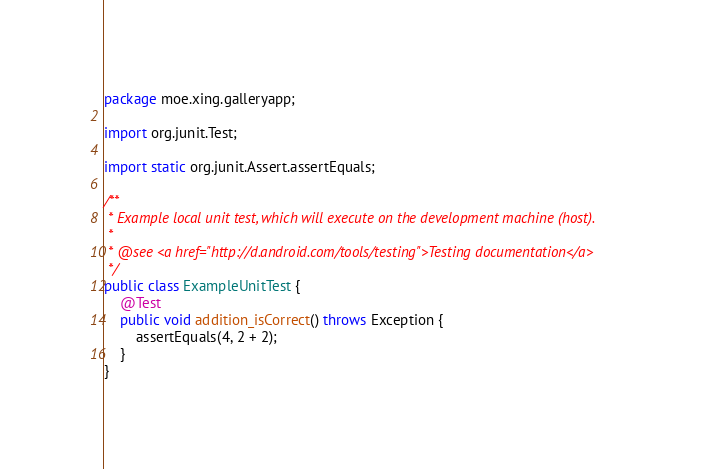Convert code to text. <code><loc_0><loc_0><loc_500><loc_500><_Java_>package moe.xing.galleryapp;

import org.junit.Test;

import static org.junit.Assert.assertEquals;

/**
 * Example local unit test, which will execute on the development machine (host).
 *
 * @see <a href="http://d.android.com/tools/testing">Testing documentation</a>
 */
public class ExampleUnitTest {
    @Test
    public void addition_isCorrect() throws Exception {
        assertEquals(4, 2 + 2);
    }
}</code> 